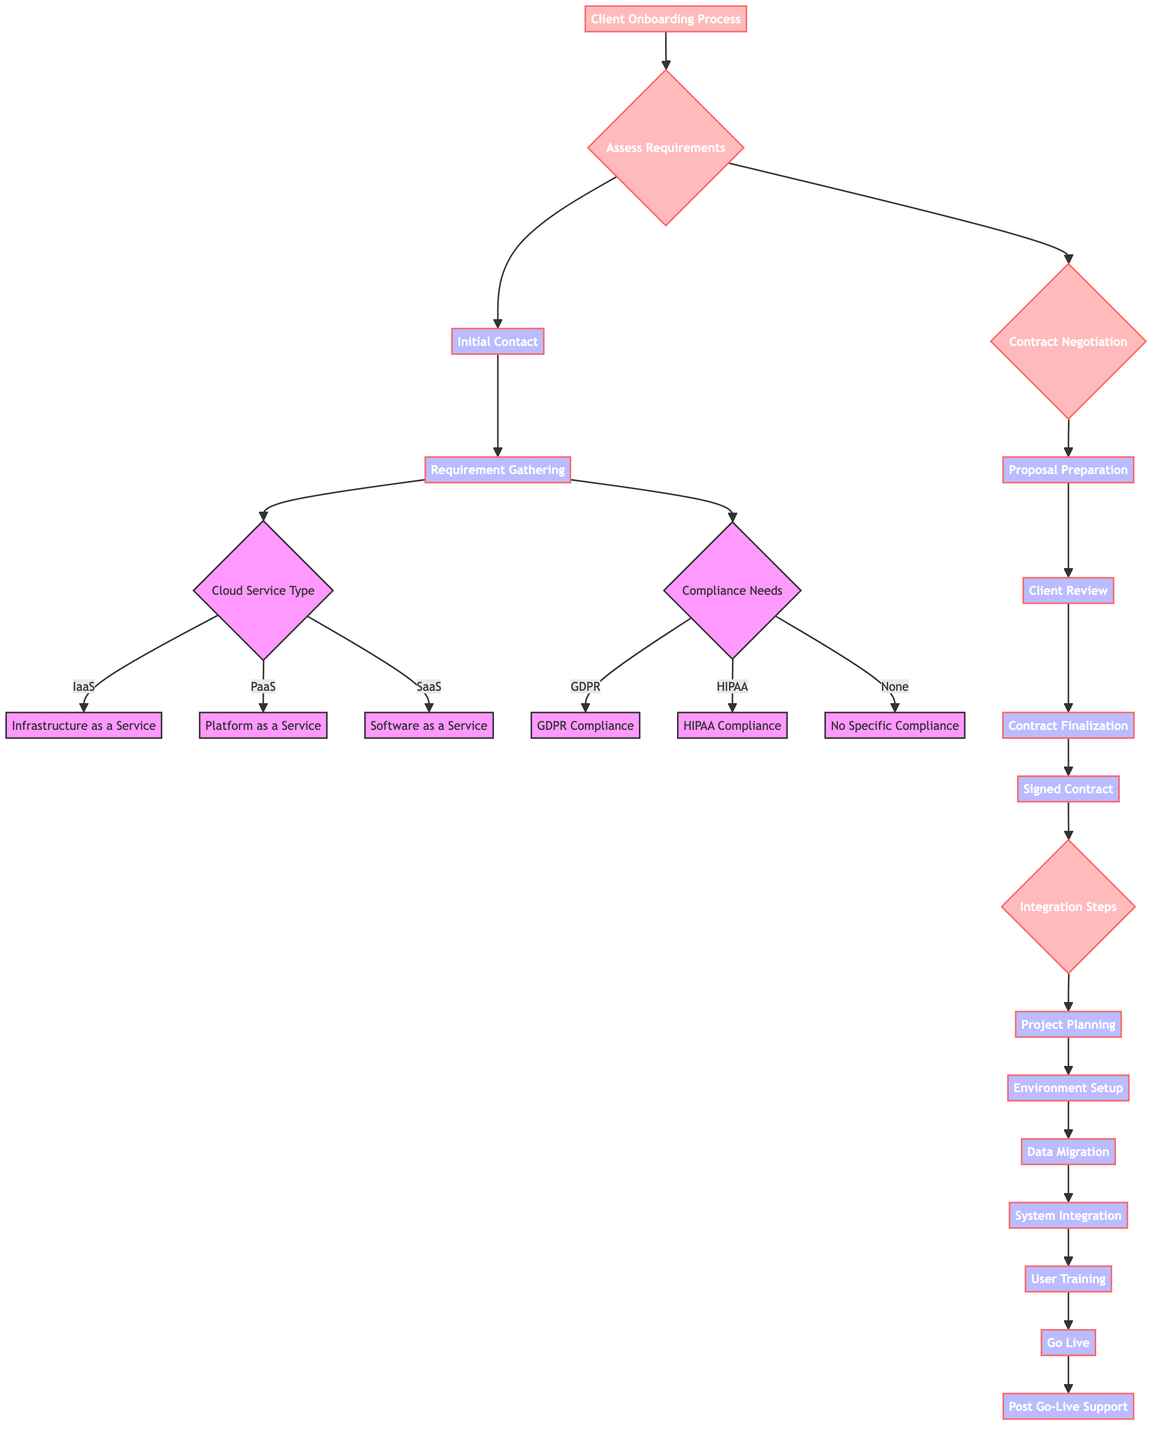What is the first step in the Client Onboarding Process? The first step is "Assess Requirements," which is the initial node in the decision tree structure that outlines the onboarding process.
Answer: Assess Requirements How many main phases are there in the Client Onboarding Process? The process consists of three main phases: "Assess Requirements," "Contract Negotiation," and "Integration Steps." These phases are visually separated and represent significant parts of the onboarding workflow.
Answer: Three What follows "Requirement Gathering"? After "Requirement Gathering," the next step is to evaluate the "Cloud Service Type" and "Compliance Needs," indicating that both aspects need to be assessed simultaneously.
Answer: Cloud Service Type and Compliance Needs Which service type pertains to "Environment Setup"? "Environment Setup" is under the "Integration Steps" phase, which is initiated following the "Signed Contract." Therefore, the context connects the integration process to the finalized contract.
Answer: Integration Steps What compliance option falls under the "Compliance Needs"? The compliance options under "Compliance Needs" include "GDPR," "HIPAA," and "None." This suggests there are multiple requirements that can be evaluated based on the client's needs.
Answer: GDPR, HIPAA, and None In how many stages does the integration process end? The integration process ends after the "Post Go-Live Support" stage, indicating this is the final step in the integration phase of the onboarding process.
Answer: One What is the last node in the diagram? The last node in the diagram is "Post Go-Live Support," representing the final phase of assistance provided to the client after their cloud solutions have gone live.
Answer: Post Go-Live Support How many steps are in the "Integration Steps" section? There are six individual steps listed under "Integration Steps": "Project Planning," "Environment Setup," "Data Migration," "System Integration," "User Training," and "Go Live." Each step leads sequentially to the next.
Answer: Six What are the steps involved after receiving a signed contract? After receiving the signed contract, the client's onboarding moves directly into the "Integration Steps," starting with "Project Planning." The flow continues sequentially through the integration process until the final support stage.
Answer: Integration Steps 